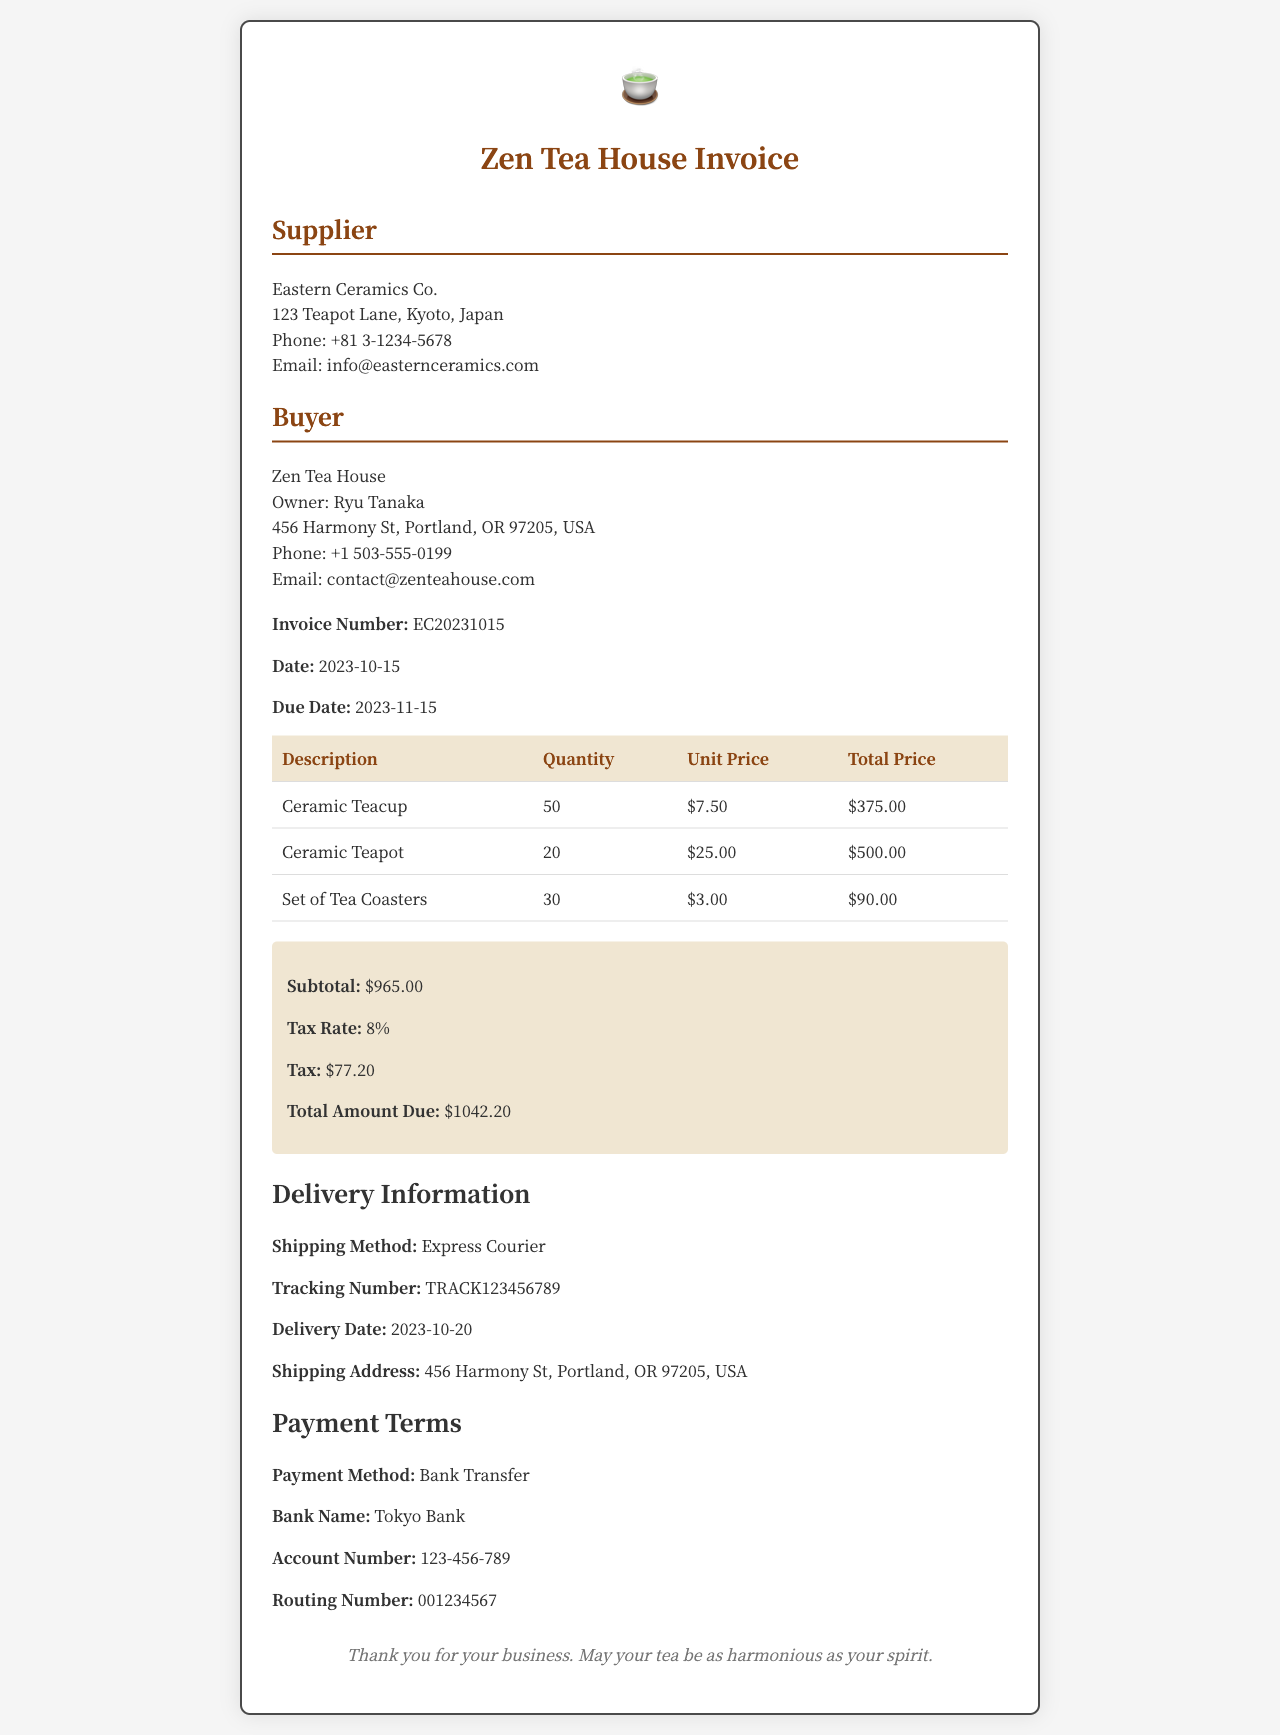What is the invoice number? The invoice number is presented in the document under invoice details.
Answer: EC20231015 What is the total amount due? The total amount due can be found in the summary section of the invoice.
Answer: $1042.20 How many ceramic teapots were ordered? The quantity of ceramic teapots ordered is specified in the itemized table.
Answer: 20 What is the tax rate applied? The tax rate is mentioned in the summary section of the invoice.
Answer: 8% Who is the supplier? The supplier's name is listed at the beginning of the invoice.
Answer: Eastern Ceramics Co What is the delivery date? The delivery date is provided in the delivery information section of the invoice.
Answer: 2023-10-20 What payment method is specified in the document? The payment method is indicated in the payment terms section of the invoice.
Answer: Bank Transfer What is the shipping method? The shipping method is described in the delivery information part of the invoice.
Answer: Express Courier 